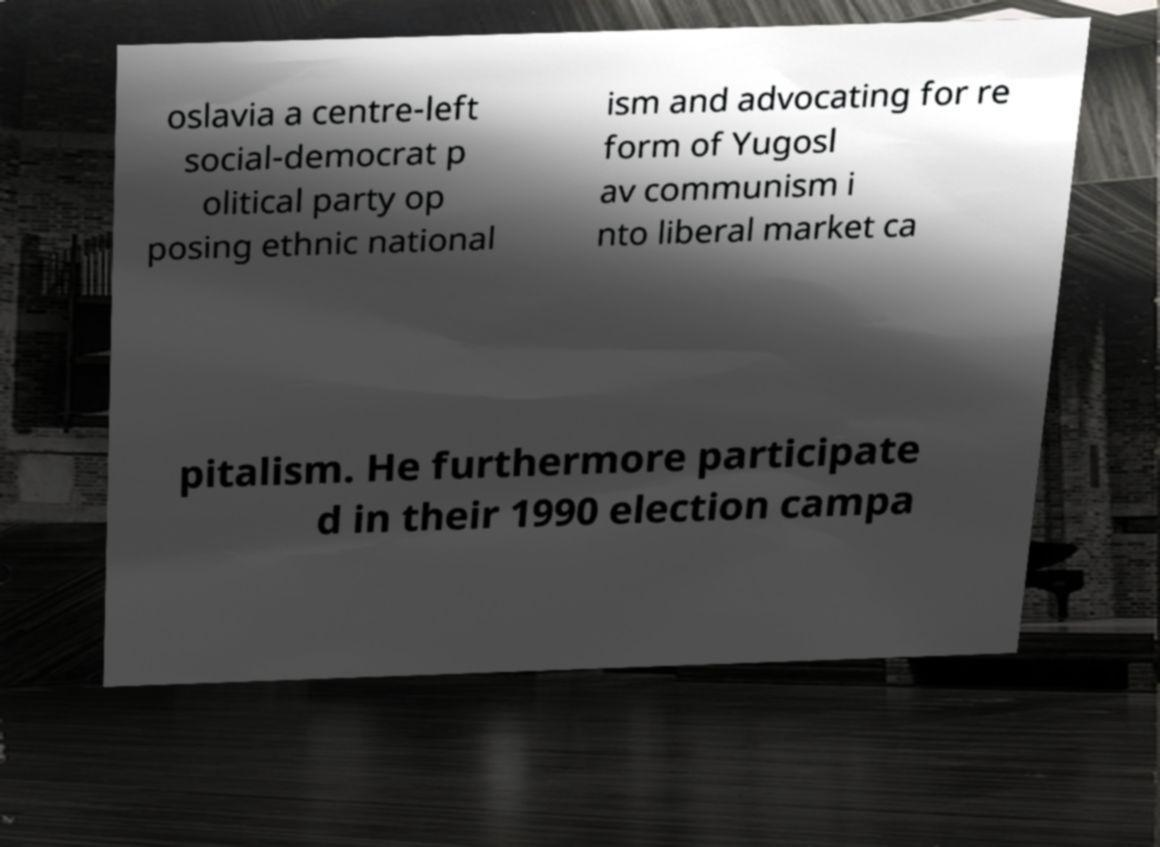Please identify and transcribe the text found in this image. oslavia a centre-left social-democrat p olitical party op posing ethnic national ism and advocating for re form of Yugosl av communism i nto liberal market ca pitalism. He furthermore participate d in their 1990 election campa 